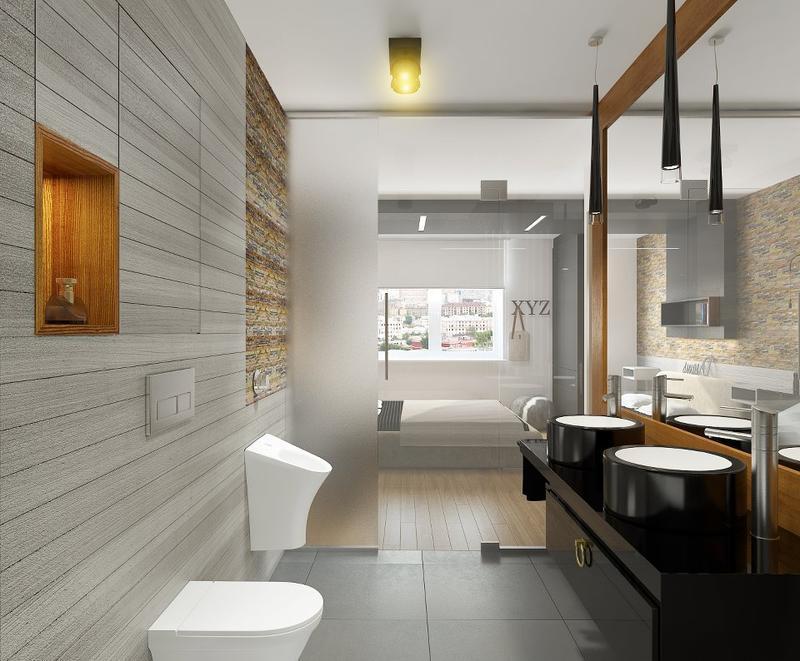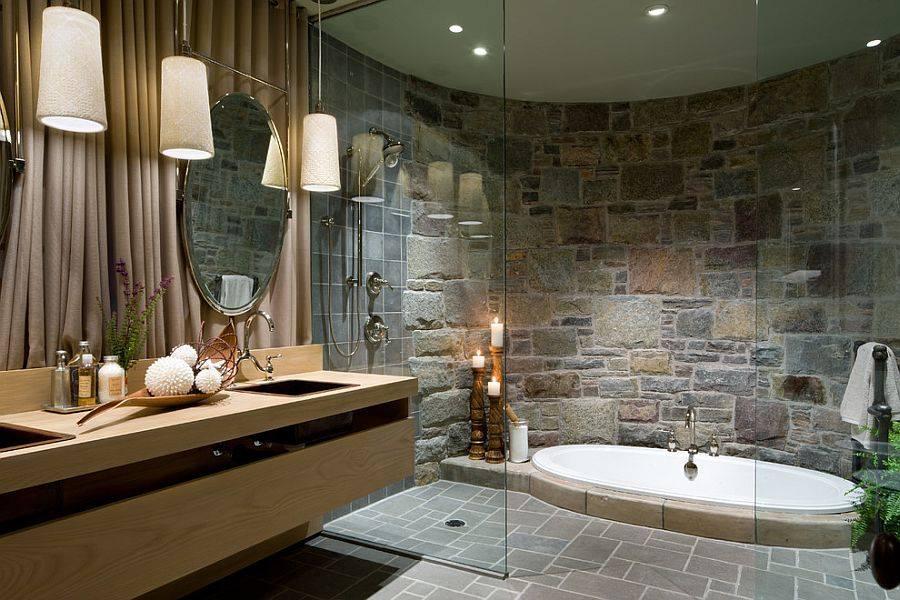The first image is the image on the left, the second image is the image on the right. Given the left and right images, does the statement "One bathroom has a long wall-mounted black vanity with separate white sinks, and the other bathroom has a round bathtub and double square sinks." hold true? Answer yes or no. Yes. 